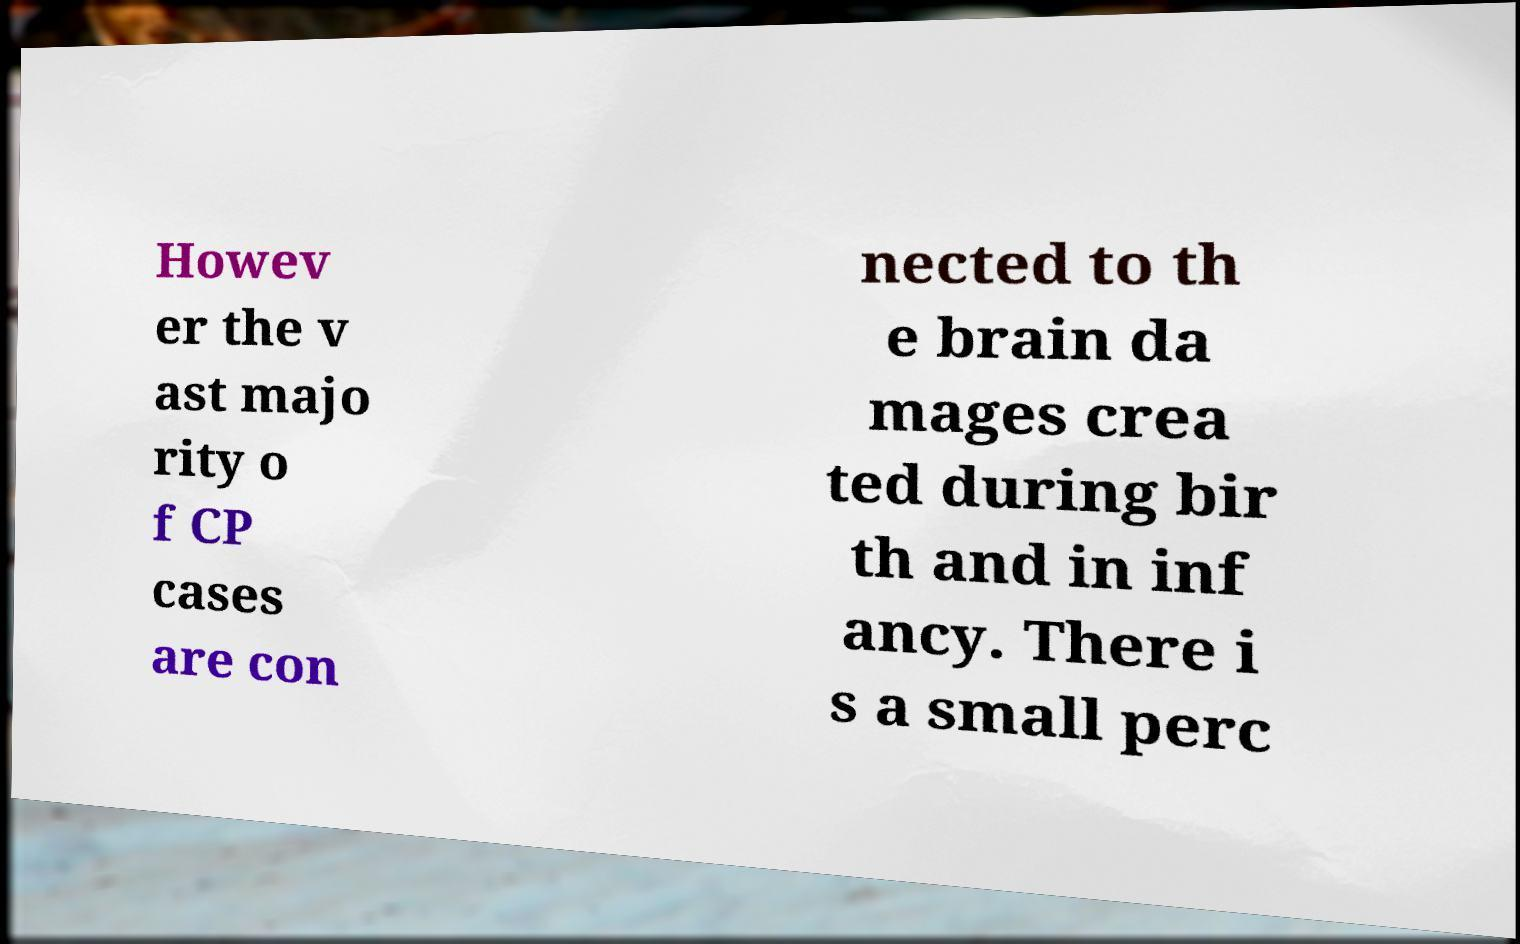Can you accurately transcribe the text from the provided image for me? Howev er the v ast majo rity o f CP cases are con nected to th e brain da mages crea ted during bir th and in inf ancy. There i s a small perc 